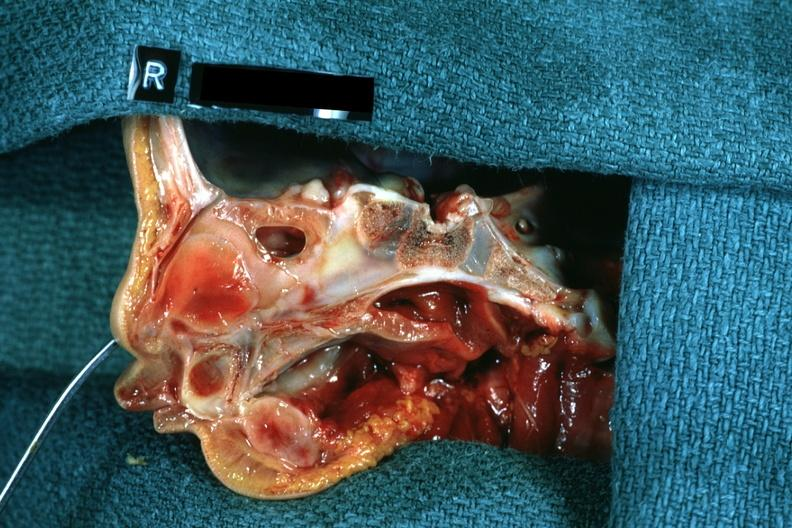s right side atresia left was patent hemisection of nose?
Answer the question using a single word or phrase. Yes 